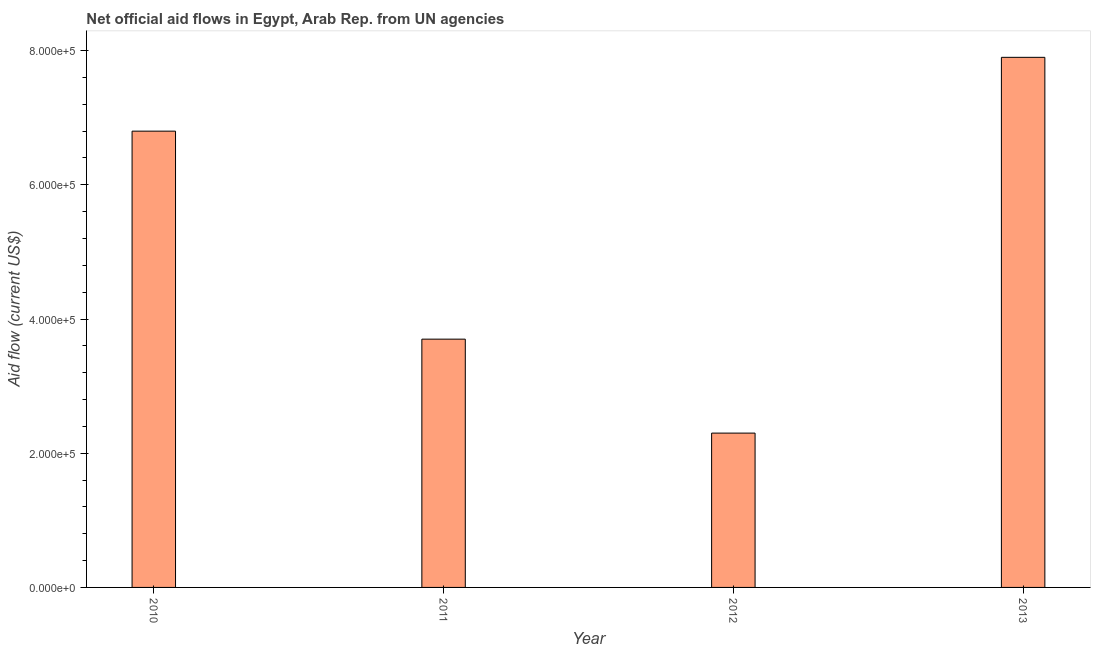Does the graph contain grids?
Offer a very short reply. No. What is the title of the graph?
Give a very brief answer. Net official aid flows in Egypt, Arab Rep. from UN agencies. What is the label or title of the X-axis?
Offer a terse response. Year. What is the label or title of the Y-axis?
Offer a very short reply. Aid flow (current US$). Across all years, what is the maximum net official flows from un agencies?
Keep it short and to the point. 7.90e+05. Across all years, what is the minimum net official flows from un agencies?
Keep it short and to the point. 2.30e+05. In which year was the net official flows from un agencies minimum?
Provide a short and direct response. 2012. What is the sum of the net official flows from un agencies?
Your answer should be compact. 2.07e+06. What is the average net official flows from un agencies per year?
Make the answer very short. 5.18e+05. What is the median net official flows from un agencies?
Offer a terse response. 5.25e+05. What is the ratio of the net official flows from un agencies in 2011 to that in 2013?
Offer a very short reply. 0.47. Is the net official flows from un agencies in 2011 less than that in 2012?
Your answer should be very brief. No. Is the difference between the net official flows from un agencies in 2010 and 2012 greater than the difference between any two years?
Provide a succinct answer. No. What is the difference between the highest and the second highest net official flows from un agencies?
Make the answer very short. 1.10e+05. Is the sum of the net official flows from un agencies in 2010 and 2012 greater than the maximum net official flows from un agencies across all years?
Your answer should be compact. Yes. What is the difference between the highest and the lowest net official flows from un agencies?
Provide a succinct answer. 5.60e+05. In how many years, is the net official flows from un agencies greater than the average net official flows from un agencies taken over all years?
Ensure brevity in your answer.  2. How many bars are there?
Provide a succinct answer. 4. Are all the bars in the graph horizontal?
Make the answer very short. No. How many years are there in the graph?
Your response must be concise. 4. What is the Aid flow (current US$) of 2010?
Your answer should be very brief. 6.80e+05. What is the Aid flow (current US$) of 2011?
Your response must be concise. 3.70e+05. What is the Aid flow (current US$) of 2012?
Offer a very short reply. 2.30e+05. What is the Aid flow (current US$) of 2013?
Provide a short and direct response. 7.90e+05. What is the difference between the Aid flow (current US$) in 2010 and 2011?
Your answer should be compact. 3.10e+05. What is the difference between the Aid flow (current US$) in 2010 and 2013?
Your answer should be very brief. -1.10e+05. What is the difference between the Aid flow (current US$) in 2011 and 2012?
Ensure brevity in your answer.  1.40e+05. What is the difference between the Aid flow (current US$) in 2011 and 2013?
Your answer should be compact. -4.20e+05. What is the difference between the Aid flow (current US$) in 2012 and 2013?
Keep it short and to the point. -5.60e+05. What is the ratio of the Aid flow (current US$) in 2010 to that in 2011?
Offer a terse response. 1.84. What is the ratio of the Aid flow (current US$) in 2010 to that in 2012?
Keep it short and to the point. 2.96. What is the ratio of the Aid flow (current US$) in 2010 to that in 2013?
Give a very brief answer. 0.86. What is the ratio of the Aid flow (current US$) in 2011 to that in 2012?
Make the answer very short. 1.61. What is the ratio of the Aid flow (current US$) in 2011 to that in 2013?
Offer a very short reply. 0.47. What is the ratio of the Aid flow (current US$) in 2012 to that in 2013?
Ensure brevity in your answer.  0.29. 